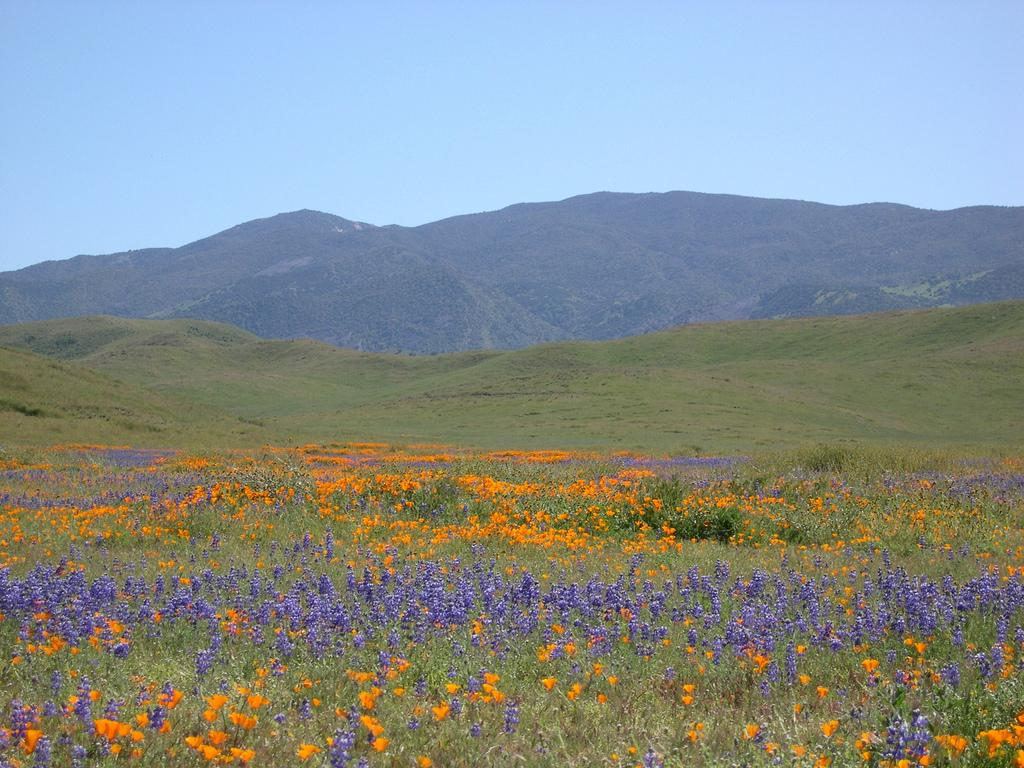What type of vegetation can be seen in the image? There are flowers, plants, and grass visible in the image. What can be seen in the background of the image? There are hills visible in the background of the image. What type of fork can be seen in the image? There is no fork present in the image. Is there a hospital visible in the image? There is no hospital present in the image. 